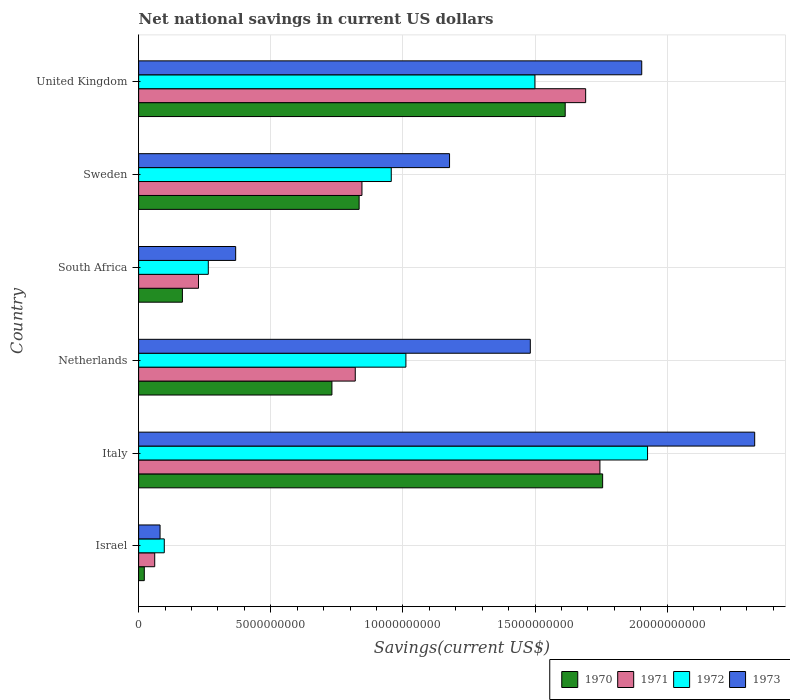How many different coloured bars are there?
Provide a short and direct response. 4. How many groups of bars are there?
Provide a succinct answer. 6. How many bars are there on the 3rd tick from the top?
Offer a very short reply. 4. How many bars are there on the 3rd tick from the bottom?
Provide a succinct answer. 4. What is the label of the 2nd group of bars from the top?
Offer a terse response. Sweden. In how many cases, is the number of bars for a given country not equal to the number of legend labels?
Give a very brief answer. 0. What is the net national savings in 1972 in United Kingdom?
Your answer should be very brief. 1.50e+1. Across all countries, what is the maximum net national savings in 1970?
Offer a very short reply. 1.76e+1. Across all countries, what is the minimum net national savings in 1973?
Provide a short and direct response. 8.11e+08. In which country was the net national savings in 1973 maximum?
Offer a terse response. Italy. What is the total net national savings in 1972 in the graph?
Your answer should be compact. 5.75e+1. What is the difference between the net national savings in 1972 in Israel and that in United Kingdom?
Your answer should be compact. -1.40e+1. What is the difference between the net national savings in 1972 in United Kingdom and the net national savings in 1970 in Israel?
Ensure brevity in your answer.  1.48e+1. What is the average net national savings in 1970 per country?
Give a very brief answer. 8.54e+09. What is the difference between the net national savings in 1973 and net national savings in 1971 in Israel?
Provide a short and direct response. 2.02e+08. What is the ratio of the net national savings in 1972 in Netherlands to that in United Kingdom?
Ensure brevity in your answer.  0.67. What is the difference between the highest and the second highest net national savings in 1971?
Make the answer very short. 5.40e+08. What is the difference between the highest and the lowest net national savings in 1971?
Provide a succinct answer. 1.68e+1. In how many countries, is the net national savings in 1972 greater than the average net national savings in 1972 taken over all countries?
Your answer should be very brief. 3. Is the sum of the net national savings in 1970 in South Africa and United Kingdom greater than the maximum net national savings in 1972 across all countries?
Keep it short and to the point. No. Is it the case that in every country, the sum of the net national savings in 1973 and net national savings in 1972 is greater than the sum of net national savings in 1970 and net national savings in 1971?
Offer a terse response. No. What does the 1st bar from the bottom in Netherlands represents?
Ensure brevity in your answer.  1970. How many bars are there?
Keep it short and to the point. 24. How many countries are there in the graph?
Make the answer very short. 6. How many legend labels are there?
Provide a short and direct response. 4. How are the legend labels stacked?
Make the answer very short. Horizontal. What is the title of the graph?
Provide a succinct answer. Net national savings in current US dollars. What is the label or title of the X-axis?
Provide a short and direct response. Savings(current US$). What is the Savings(current US$) in 1970 in Israel?
Your response must be concise. 2.15e+08. What is the Savings(current US$) in 1971 in Israel?
Offer a terse response. 6.09e+08. What is the Savings(current US$) in 1972 in Israel?
Offer a very short reply. 9.71e+08. What is the Savings(current US$) of 1973 in Israel?
Your answer should be very brief. 8.11e+08. What is the Savings(current US$) in 1970 in Italy?
Ensure brevity in your answer.  1.76e+1. What is the Savings(current US$) in 1971 in Italy?
Provide a succinct answer. 1.75e+1. What is the Savings(current US$) in 1972 in Italy?
Offer a terse response. 1.93e+1. What is the Savings(current US$) in 1973 in Italy?
Ensure brevity in your answer.  2.33e+1. What is the Savings(current US$) in 1970 in Netherlands?
Your response must be concise. 7.31e+09. What is the Savings(current US$) of 1971 in Netherlands?
Offer a very short reply. 8.20e+09. What is the Savings(current US$) in 1972 in Netherlands?
Offer a terse response. 1.01e+1. What is the Savings(current US$) in 1973 in Netherlands?
Ensure brevity in your answer.  1.48e+1. What is the Savings(current US$) of 1970 in South Africa?
Offer a very short reply. 1.66e+09. What is the Savings(current US$) in 1971 in South Africa?
Ensure brevity in your answer.  2.27e+09. What is the Savings(current US$) of 1972 in South Africa?
Offer a terse response. 2.64e+09. What is the Savings(current US$) in 1973 in South Africa?
Provide a succinct answer. 3.67e+09. What is the Savings(current US$) of 1970 in Sweden?
Offer a terse response. 8.34e+09. What is the Savings(current US$) in 1971 in Sweden?
Keep it short and to the point. 8.45e+09. What is the Savings(current US$) of 1972 in Sweden?
Provide a succinct answer. 9.56e+09. What is the Savings(current US$) in 1973 in Sweden?
Give a very brief answer. 1.18e+1. What is the Savings(current US$) of 1970 in United Kingdom?
Make the answer very short. 1.61e+1. What is the Savings(current US$) of 1971 in United Kingdom?
Your response must be concise. 1.69e+1. What is the Savings(current US$) in 1972 in United Kingdom?
Offer a very short reply. 1.50e+1. What is the Savings(current US$) of 1973 in United Kingdom?
Your response must be concise. 1.90e+1. Across all countries, what is the maximum Savings(current US$) in 1970?
Provide a short and direct response. 1.76e+1. Across all countries, what is the maximum Savings(current US$) in 1971?
Ensure brevity in your answer.  1.75e+1. Across all countries, what is the maximum Savings(current US$) in 1972?
Make the answer very short. 1.93e+1. Across all countries, what is the maximum Savings(current US$) of 1973?
Keep it short and to the point. 2.33e+1. Across all countries, what is the minimum Savings(current US$) of 1970?
Make the answer very short. 2.15e+08. Across all countries, what is the minimum Savings(current US$) of 1971?
Your answer should be very brief. 6.09e+08. Across all countries, what is the minimum Savings(current US$) of 1972?
Ensure brevity in your answer.  9.71e+08. Across all countries, what is the minimum Savings(current US$) in 1973?
Ensure brevity in your answer.  8.11e+08. What is the total Savings(current US$) of 1970 in the graph?
Ensure brevity in your answer.  5.12e+1. What is the total Savings(current US$) in 1971 in the graph?
Offer a very short reply. 5.39e+1. What is the total Savings(current US$) in 1972 in the graph?
Provide a short and direct response. 5.75e+1. What is the total Savings(current US$) of 1973 in the graph?
Ensure brevity in your answer.  7.34e+1. What is the difference between the Savings(current US$) of 1970 in Israel and that in Italy?
Ensure brevity in your answer.  -1.73e+1. What is the difference between the Savings(current US$) in 1971 in Israel and that in Italy?
Provide a short and direct response. -1.68e+1. What is the difference between the Savings(current US$) in 1972 in Israel and that in Italy?
Provide a succinct answer. -1.83e+1. What is the difference between the Savings(current US$) in 1973 in Israel and that in Italy?
Your answer should be compact. -2.25e+1. What is the difference between the Savings(current US$) of 1970 in Israel and that in Netherlands?
Give a very brief answer. -7.10e+09. What is the difference between the Savings(current US$) of 1971 in Israel and that in Netherlands?
Your answer should be very brief. -7.59e+09. What is the difference between the Savings(current US$) of 1972 in Israel and that in Netherlands?
Offer a very short reply. -9.14e+09. What is the difference between the Savings(current US$) of 1973 in Israel and that in Netherlands?
Make the answer very short. -1.40e+1. What is the difference between the Savings(current US$) in 1970 in Israel and that in South Africa?
Offer a very short reply. -1.44e+09. What is the difference between the Savings(current US$) in 1971 in Israel and that in South Africa?
Make the answer very short. -1.66e+09. What is the difference between the Savings(current US$) in 1972 in Israel and that in South Africa?
Ensure brevity in your answer.  -1.66e+09. What is the difference between the Savings(current US$) in 1973 in Israel and that in South Africa?
Provide a short and direct response. -2.86e+09. What is the difference between the Savings(current US$) of 1970 in Israel and that in Sweden?
Your answer should be very brief. -8.13e+09. What is the difference between the Savings(current US$) of 1971 in Israel and that in Sweden?
Make the answer very short. -7.84e+09. What is the difference between the Savings(current US$) in 1972 in Israel and that in Sweden?
Your answer should be compact. -8.59e+09. What is the difference between the Savings(current US$) in 1973 in Israel and that in Sweden?
Your answer should be compact. -1.10e+1. What is the difference between the Savings(current US$) in 1970 in Israel and that in United Kingdom?
Give a very brief answer. -1.59e+1. What is the difference between the Savings(current US$) of 1971 in Israel and that in United Kingdom?
Make the answer very short. -1.63e+1. What is the difference between the Savings(current US$) of 1972 in Israel and that in United Kingdom?
Make the answer very short. -1.40e+1. What is the difference between the Savings(current US$) of 1973 in Israel and that in United Kingdom?
Your answer should be very brief. -1.82e+1. What is the difference between the Savings(current US$) in 1970 in Italy and that in Netherlands?
Provide a succinct answer. 1.02e+1. What is the difference between the Savings(current US$) of 1971 in Italy and that in Netherlands?
Your response must be concise. 9.26e+09. What is the difference between the Savings(current US$) in 1972 in Italy and that in Netherlands?
Ensure brevity in your answer.  9.14e+09. What is the difference between the Savings(current US$) of 1973 in Italy and that in Netherlands?
Offer a terse response. 8.49e+09. What is the difference between the Savings(current US$) in 1970 in Italy and that in South Africa?
Your response must be concise. 1.59e+1. What is the difference between the Savings(current US$) in 1971 in Italy and that in South Africa?
Ensure brevity in your answer.  1.52e+1. What is the difference between the Savings(current US$) of 1972 in Italy and that in South Africa?
Provide a short and direct response. 1.66e+1. What is the difference between the Savings(current US$) in 1973 in Italy and that in South Africa?
Your response must be concise. 1.96e+1. What is the difference between the Savings(current US$) of 1970 in Italy and that in Sweden?
Provide a short and direct response. 9.21e+09. What is the difference between the Savings(current US$) of 1971 in Italy and that in Sweden?
Provide a succinct answer. 9.00e+09. What is the difference between the Savings(current US$) of 1972 in Italy and that in Sweden?
Ensure brevity in your answer.  9.70e+09. What is the difference between the Savings(current US$) in 1973 in Italy and that in Sweden?
Your answer should be very brief. 1.15e+1. What is the difference between the Savings(current US$) in 1970 in Italy and that in United Kingdom?
Your answer should be compact. 1.42e+09. What is the difference between the Savings(current US$) of 1971 in Italy and that in United Kingdom?
Give a very brief answer. 5.40e+08. What is the difference between the Savings(current US$) of 1972 in Italy and that in United Kingdom?
Your response must be concise. 4.26e+09. What is the difference between the Savings(current US$) in 1973 in Italy and that in United Kingdom?
Offer a terse response. 4.27e+09. What is the difference between the Savings(current US$) in 1970 in Netherlands and that in South Africa?
Keep it short and to the point. 5.66e+09. What is the difference between the Savings(current US$) in 1971 in Netherlands and that in South Africa?
Provide a short and direct response. 5.93e+09. What is the difference between the Savings(current US$) of 1972 in Netherlands and that in South Africa?
Offer a terse response. 7.48e+09. What is the difference between the Savings(current US$) of 1973 in Netherlands and that in South Africa?
Give a very brief answer. 1.11e+1. What is the difference between the Savings(current US$) of 1970 in Netherlands and that in Sweden?
Offer a very short reply. -1.03e+09. What is the difference between the Savings(current US$) of 1971 in Netherlands and that in Sweden?
Provide a succinct answer. -2.53e+08. What is the difference between the Savings(current US$) in 1972 in Netherlands and that in Sweden?
Keep it short and to the point. 5.54e+08. What is the difference between the Savings(current US$) in 1973 in Netherlands and that in Sweden?
Offer a terse response. 3.06e+09. What is the difference between the Savings(current US$) in 1970 in Netherlands and that in United Kingdom?
Your response must be concise. -8.83e+09. What is the difference between the Savings(current US$) of 1971 in Netherlands and that in United Kingdom?
Your answer should be compact. -8.72e+09. What is the difference between the Savings(current US$) in 1972 in Netherlands and that in United Kingdom?
Your answer should be very brief. -4.88e+09. What is the difference between the Savings(current US$) of 1973 in Netherlands and that in United Kingdom?
Make the answer very short. -4.22e+09. What is the difference between the Savings(current US$) of 1970 in South Africa and that in Sweden?
Your answer should be compact. -6.69e+09. What is the difference between the Savings(current US$) in 1971 in South Africa and that in Sweden?
Keep it short and to the point. -6.18e+09. What is the difference between the Savings(current US$) in 1972 in South Africa and that in Sweden?
Offer a terse response. -6.92e+09. What is the difference between the Savings(current US$) in 1973 in South Africa and that in Sweden?
Provide a short and direct response. -8.09e+09. What is the difference between the Savings(current US$) in 1970 in South Africa and that in United Kingdom?
Give a very brief answer. -1.45e+1. What is the difference between the Savings(current US$) in 1971 in South Africa and that in United Kingdom?
Provide a short and direct response. -1.46e+1. What is the difference between the Savings(current US$) in 1972 in South Africa and that in United Kingdom?
Provide a short and direct response. -1.24e+1. What is the difference between the Savings(current US$) of 1973 in South Africa and that in United Kingdom?
Offer a very short reply. -1.54e+1. What is the difference between the Savings(current US$) of 1970 in Sweden and that in United Kingdom?
Provide a short and direct response. -7.80e+09. What is the difference between the Savings(current US$) in 1971 in Sweden and that in United Kingdom?
Your answer should be very brief. -8.46e+09. What is the difference between the Savings(current US$) of 1972 in Sweden and that in United Kingdom?
Your answer should be compact. -5.43e+09. What is the difference between the Savings(current US$) in 1973 in Sweden and that in United Kingdom?
Offer a very short reply. -7.27e+09. What is the difference between the Savings(current US$) of 1970 in Israel and the Savings(current US$) of 1971 in Italy?
Offer a very short reply. -1.72e+1. What is the difference between the Savings(current US$) in 1970 in Israel and the Savings(current US$) in 1972 in Italy?
Keep it short and to the point. -1.90e+1. What is the difference between the Savings(current US$) of 1970 in Israel and the Savings(current US$) of 1973 in Italy?
Ensure brevity in your answer.  -2.31e+1. What is the difference between the Savings(current US$) of 1971 in Israel and the Savings(current US$) of 1972 in Italy?
Your answer should be very brief. -1.86e+1. What is the difference between the Savings(current US$) of 1971 in Israel and the Savings(current US$) of 1973 in Italy?
Provide a succinct answer. -2.27e+1. What is the difference between the Savings(current US$) of 1972 in Israel and the Savings(current US$) of 1973 in Italy?
Give a very brief answer. -2.23e+1. What is the difference between the Savings(current US$) in 1970 in Israel and the Savings(current US$) in 1971 in Netherlands?
Your response must be concise. -7.98e+09. What is the difference between the Savings(current US$) in 1970 in Israel and the Savings(current US$) in 1972 in Netherlands?
Offer a terse response. -9.90e+09. What is the difference between the Savings(current US$) in 1970 in Israel and the Savings(current US$) in 1973 in Netherlands?
Provide a succinct answer. -1.46e+1. What is the difference between the Savings(current US$) of 1971 in Israel and the Savings(current US$) of 1972 in Netherlands?
Make the answer very short. -9.50e+09. What is the difference between the Savings(current US$) in 1971 in Israel and the Savings(current US$) in 1973 in Netherlands?
Offer a very short reply. -1.42e+1. What is the difference between the Savings(current US$) of 1972 in Israel and the Savings(current US$) of 1973 in Netherlands?
Your response must be concise. -1.38e+1. What is the difference between the Savings(current US$) of 1970 in Israel and the Savings(current US$) of 1971 in South Africa?
Your response must be concise. -2.05e+09. What is the difference between the Savings(current US$) of 1970 in Israel and the Savings(current US$) of 1972 in South Africa?
Your answer should be compact. -2.42e+09. What is the difference between the Savings(current US$) in 1970 in Israel and the Savings(current US$) in 1973 in South Africa?
Provide a succinct answer. -3.46e+09. What is the difference between the Savings(current US$) of 1971 in Israel and the Savings(current US$) of 1972 in South Africa?
Keep it short and to the point. -2.03e+09. What is the difference between the Savings(current US$) of 1971 in Israel and the Savings(current US$) of 1973 in South Africa?
Provide a short and direct response. -3.06e+09. What is the difference between the Savings(current US$) of 1972 in Israel and the Savings(current US$) of 1973 in South Africa?
Make the answer very short. -2.70e+09. What is the difference between the Savings(current US$) in 1970 in Israel and the Savings(current US$) in 1971 in Sweden?
Your answer should be very brief. -8.23e+09. What is the difference between the Savings(current US$) of 1970 in Israel and the Savings(current US$) of 1972 in Sweden?
Make the answer very short. -9.34e+09. What is the difference between the Savings(current US$) of 1970 in Israel and the Savings(current US$) of 1973 in Sweden?
Make the answer very short. -1.15e+1. What is the difference between the Savings(current US$) in 1971 in Israel and the Savings(current US$) in 1972 in Sweden?
Your response must be concise. -8.95e+09. What is the difference between the Savings(current US$) of 1971 in Israel and the Savings(current US$) of 1973 in Sweden?
Your response must be concise. -1.12e+1. What is the difference between the Savings(current US$) in 1972 in Israel and the Savings(current US$) in 1973 in Sweden?
Your response must be concise. -1.08e+1. What is the difference between the Savings(current US$) of 1970 in Israel and the Savings(current US$) of 1971 in United Kingdom?
Provide a short and direct response. -1.67e+1. What is the difference between the Savings(current US$) in 1970 in Israel and the Savings(current US$) in 1972 in United Kingdom?
Provide a succinct answer. -1.48e+1. What is the difference between the Savings(current US$) of 1970 in Israel and the Savings(current US$) of 1973 in United Kingdom?
Offer a terse response. -1.88e+1. What is the difference between the Savings(current US$) of 1971 in Israel and the Savings(current US$) of 1972 in United Kingdom?
Offer a very short reply. -1.44e+1. What is the difference between the Savings(current US$) in 1971 in Israel and the Savings(current US$) in 1973 in United Kingdom?
Your response must be concise. -1.84e+1. What is the difference between the Savings(current US$) of 1972 in Israel and the Savings(current US$) of 1973 in United Kingdom?
Provide a succinct answer. -1.81e+1. What is the difference between the Savings(current US$) of 1970 in Italy and the Savings(current US$) of 1971 in Netherlands?
Ensure brevity in your answer.  9.36e+09. What is the difference between the Savings(current US$) of 1970 in Italy and the Savings(current US$) of 1972 in Netherlands?
Ensure brevity in your answer.  7.44e+09. What is the difference between the Savings(current US$) of 1970 in Italy and the Savings(current US$) of 1973 in Netherlands?
Your answer should be very brief. 2.74e+09. What is the difference between the Savings(current US$) in 1971 in Italy and the Savings(current US$) in 1972 in Netherlands?
Provide a short and direct response. 7.34e+09. What is the difference between the Savings(current US$) in 1971 in Italy and the Savings(current US$) in 1973 in Netherlands?
Give a very brief answer. 2.63e+09. What is the difference between the Savings(current US$) in 1972 in Italy and the Savings(current US$) in 1973 in Netherlands?
Give a very brief answer. 4.44e+09. What is the difference between the Savings(current US$) of 1970 in Italy and the Savings(current US$) of 1971 in South Africa?
Your answer should be compact. 1.53e+1. What is the difference between the Savings(current US$) of 1970 in Italy and the Savings(current US$) of 1972 in South Africa?
Offer a very short reply. 1.49e+1. What is the difference between the Savings(current US$) of 1970 in Italy and the Savings(current US$) of 1973 in South Africa?
Ensure brevity in your answer.  1.39e+1. What is the difference between the Savings(current US$) of 1971 in Italy and the Savings(current US$) of 1972 in South Africa?
Provide a succinct answer. 1.48e+1. What is the difference between the Savings(current US$) of 1971 in Italy and the Savings(current US$) of 1973 in South Africa?
Offer a terse response. 1.38e+1. What is the difference between the Savings(current US$) of 1972 in Italy and the Savings(current US$) of 1973 in South Africa?
Your response must be concise. 1.56e+1. What is the difference between the Savings(current US$) in 1970 in Italy and the Savings(current US$) in 1971 in Sweden?
Provide a short and direct response. 9.11e+09. What is the difference between the Savings(current US$) in 1970 in Italy and the Savings(current US$) in 1972 in Sweden?
Offer a very short reply. 8.00e+09. What is the difference between the Savings(current US$) of 1970 in Italy and the Savings(current US$) of 1973 in Sweden?
Your answer should be very brief. 5.79e+09. What is the difference between the Savings(current US$) of 1971 in Italy and the Savings(current US$) of 1972 in Sweden?
Provide a short and direct response. 7.89e+09. What is the difference between the Savings(current US$) of 1971 in Italy and the Savings(current US$) of 1973 in Sweden?
Give a very brief answer. 5.69e+09. What is the difference between the Savings(current US$) of 1972 in Italy and the Savings(current US$) of 1973 in Sweden?
Provide a short and direct response. 7.49e+09. What is the difference between the Savings(current US$) of 1970 in Italy and the Savings(current US$) of 1971 in United Kingdom?
Provide a succinct answer. 6.43e+08. What is the difference between the Savings(current US$) of 1970 in Italy and the Savings(current US$) of 1972 in United Kingdom?
Your answer should be compact. 2.56e+09. What is the difference between the Savings(current US$) of 1970 in Italy and the Savings(current US$) of 1973 in United Kingdom?
Your response must be concise. -1.48e+09. What is the difference between the Savings(current US$) of 1971 in Italy and the Savings(current US$) of 1972 in United Kingdom?
Provide a short and direct response. 2.46e+09. What is the difference between the Savings(current US$) of 1971 in Italy and the Savings(current US$) of 1973 in United Kingdom?
Keep it short and to the point. -1.58e+09. What is the difference between the Savings(current US$) of 1972 in Italy and the Savings(current US$) of 1973 in United Kingdom?
Give a very brief answer. 2.20e+08. What is the difference between the Savings(current US$) of 1970 in Netherlands and the Savings(current US$) of 1971 in South Africa?
Provide a succinct answer. 5.05e+09. What is the difference between the Savings(current US$) of 1970 in Netherlands and the Savings(current US$) of 1972 in South Africa?
Give a very brief answer. 4.68e+09. What is the difference between the Savings(current US$) in 1970 in Netherlands and the Savings(current US$) in 1973 in South Africa?
Make the answer very short. 3.64e+09. What is the difference between the Savings(current US$) in 1971 in Netherlands and the Savings(current US$) in 1972 in South Africa?
Offer a terse response. 5.56e+09. What is the difference between the Savings(current US$) in 1971 in Netherlands and the Savings(current US$) in 1973 in South Africa?
Give a very brief answer. 4.52e+09. What is the difference between the Savings(current US$) of 1972 in Netherlands and the Savings(current US$) of 1973 in South Africa?
Your response must be concise. 6.44e+09. What is the difference between the Savings(current US$) in 1970 in Netherlands and the Savings(current US$) in 1971 in Sweden?
Make the answer very short. -1.14e+09. What is the difference between the Savings(current US$) in 1970 in Netherlands and the Savings(current US$) in 1972 in Sweden?
Give a very brief answer. -2.25e+09. What is the difference between the Savings(current US$) of 1970 in Netherlands and the Savings(current US$) of 1973 in Sweden?
Ensure brevity in your answer.  -4.45e+09. What is the difference between the Savings(current US$) in 1971 in Netherlands and the Savings(current US$) in 1972 in Sweden?
Your answer should be very brief. -1.36e+09. What is the difference between the Savings(current US$) in 1971 in Netherlands and the Savings(current US$) in 1973 in Sweden?
Offer a very short reply. -3.57e+09. What is the difference between the Savings(current US$) of 1972 in Netherlands and the Savings(current US$) of 1973 in Sweden?
Offer a terse response. -1.65e+09. What is the difference between the Savings(current US$) in 1970 in Netherlands and the Savings(current US$) in 1971 in United Kingdom?
Provide a short and direct response. -9.60e+09. What is the difference between the Savings(current US$) in 1970 in Netherlands and the Savings(current US$) in 1972 in United Kingdom?
Offer a terse response. -7.68e+09. What is the difference between the Savings(current US$) of 1970 in Netherlands and the Savings(current US$) of 1973 in United Kingdom?
Keep it short and to the point. -1.17e+1. What is the difference between the Savings(current US$) in 1971 in Netherlands and the Savings(current US$) in 1972 in United Kingdom?
Give a very brief answer. -6.80e+09. What is the difference between the Savings(current US$) in 1971 in Netherlands and the Savings(current US$) in 1973 in United Kingdom?
Ensure brevity in your answer.  -1.08e+1. What is the difference between the Savings(current US$) of 1972 in Netherlands and the Savings(current US$) of 1973 in United Kingdom?
Your answer should be very brief. -8.92e+09. What is the difference between the Savings(current US$) of 1970 in South Africa and the Savings(current US$) of 1971 in Sweden?
Provide a short and direct response. -6.79e+09. What is the difference between the Savings(current US$) in 1970 in South Africa and the Savings(current US$) in 1972 in Sweden?
Your response must be concise. -7.90e+09. What is the difference between the Savings(current US$) of 1970 in South Africa and the Savings(current US$) of 1973 in Sweden?
Your response must be concise. -1.01e+1. What is the difference between the Savings(current US$) of 1971 in South Africa and the Savings(current US$) of 1972 in Sweden?
Provide a short and direct response. -7.29e+09. What is the difference between the Savings(current US$) of 1971 in South Africa and the Savings(current US$) of 1973 in Sweden?
Provide a succinct answer. -9.50e+09. What is the difference between the Savings(current US$) in 1972 in South Africa and the Savings(current US$) in 1973 in Sweden?
Your response must be concise. -9.13e+09. What is the difference between the Savings(current US$) of 1970 in South Africa and the Savings(current US$) of 1971 in United Kingdom?
Your answer should be very brief. -1.53e+1. What is the difference between the Savings(current US$) in 1970 in South Africa and the Savings(current US$) in 1972 in United Kingdom?
Make the answer very short. -1.33e+1. What is the difference between the Savings(current US$) of 1970 in South Africa and the Savings(current US$) of 1973 in United Kingdom?
Your response must be concise. -1.74e+1. What is the difference between the Savings(current US$) in 1971 in South Africa and the Savings(current US$) in 1972 in United Kingdom?
Offer a very short reply. -1.27e+1. What is the difference between the Savings(current US$) of 1971 in South Africa and the Savings(current US$) of 1973 in United Kingdom?
Give a very brief answer. -1.68e+1. What is the difference between the Savings(current US$) in 1972 in South Africa and the Savings(current US$) in 1973 in United Kingdom?
Keep it short and to the point. -1.64e+1. What is the difference between the Savings(current US$) in 1970 in Sweden and the Savings(current US$) in 1971 in United Kingdom?
Give a very brief answer. -8.57e+09. What is the difference between the Savings(current US$) of 1970 in Sweden and the Savings(current US$) of 1972 in United Kingdom?
Offer a terse response. -6.65e+09. What is the difference between the Savings(current US$) in 1970 in Sweden and the Savings(current US$) in 1973 in United Kingdom?
Provide a succinct answer. -1.07e+1. What is the difference between the Savings(current US$) in 1971 in Sweden and the Savings(current US$) in 1972 in United Kingdom?
Give a very brief answer. -6.54e+09. What is the difference between the Savings(current US$) of 1971 in Sweden and the Savings(current US$) of 1973 in United Kingdom?
Give a very brief answer. -1.06e+1. What is the difference between the Savings(current US$) in 1972 in Sweden and the Savings(current US$) in 1973 in United Kingdom?
Provide a short and direct response. -9.48e+09. What is the average Savings(current US$) in 1970 per country?
Your answer should be compact. 8.54e+09. What is the average Savings(current US$) in 1971 per country?
Your answer should be very brief. 8.98e+09. What is the average Savings(current US$) in 1972 per country?
Provide a succinct answer. 9.59e+09. What is the average Savings(current US$) in 1973 per country?
Provide a succinct answer. 1.22e+1. What is the difference between the Savings(current US$) in 1970 and Savings(current US$) in 1971 in Israel?
Make the answer very short. -3.94e+08. What is the difference between the Savings(current US$) in 1970 and Savings(current US$) in 1972 in Israel?
Your answer should be compact. -7.56e+08. What is the difference between the Savings(current US$) of 1970 and Savings(current US$) of 1973 in Israel?
Ensure brevity in your answer.  -5.96e+08. What is the difference between the Savings(current US$) in 1971 and Savings(current US$) in 1972 in Israel?
Your answer should be compact. -3.62e+08. What is the difference between the Savings(current US$) in 1971 and Savings(current US$) in 1973 in Israel?
Keep it short and to the point. -2.02e+08. What is the difference between the Savings(current US$) of 1972 and Savings(current US$) of 1973 in Israel?
Your response must be concise. 1.60e+08. What is the difference between the Savings(current US$) of 1970 and Savings(current US$) of 1971 in Italy?
Keep it short and to the point. 1.03e+08. What is the difference between the Savings(current US$) in 1970 and Savings(current US$) in 1972 in Italy?
Keep it short and to the point. -1.70e+09. What is the difference between the Savings(current US$) in 1970 and Savings(current US$) in 1973 in Italy?
Your answer should be compact. -5.75e+09. What is the difference between the Savings(current US$) in 1971 and Savings(current US$) in 1972 in Italy?
Ensure brevity in your answer.  -1.80e+09. What is the difference between the Savings(current US$) in 1971 and Savings(current US$) in 1973 in Italy?
Give a very brief answer. -5.86e+09. What is the difference between the Savings(current US$) in 1972 and Savings(current US$) in 1973 in Italy?
Keep it short and to the point. -4.05e+09. What is the difference between the Savings(current US$) of 1970 and Savings(current US$) of 1971 in Netherlands?
Your response must be concise. -8.83e+08. What is the difference between the Savings(current US$) of 1970 and Savings(current US$) of 1972 in Netherlands?
Ensure brevity in your answer.  -2.80e+09. What is the difference between the Savings(current US$) in 1970 and Savings(current US$) in 1973 in Netherlands?
Ensure brevity in your answer.  -7.51e+09. What is the difference between the Savings(current US$) of 1971 and Savings(current US$) of 1972 in Netherlands?
Offer a terse response. -1.92e+09. What is the difference between the Savings(current US$) of 1971 and Savings(current US$) of 1973 in Netherlands?
Your answer should be very brief. -6.62e+09. What is the difference between the Savings(current US$) in 1972 and Savings(current US$) in 1973 in Netherlands?
Your answer should be compact. -4.71e+09. What is the difference between the Savings(current US$) in 1970 and Savings(current US$) in 1971 in South Africa?
Keep it short and to the point. -6.09e+08. What is the difference between the Savings(current US$) of 1970 and Savings(current US$) of 1972 in South Africa?
Keep it short and to the point. -9.79e+08. What is the difference between the Savings(current US$) of 1970 and Savings(current US$) of 1973 in South Africa?
Offer a very short reply. -2.02e+09. What is the difference between the Savings(current US$) in 1971 and Savings(current US$) in 1972 in South Africa?
Provide a succinct answer. -3.70e+08. What is the difference between the Savings(current US$) of 1971 and Savings(current US$) of 1973 in South Africa?
Your response must be concise. -1.41e+09. What is the difference between the Savings(current US$) of 1972 and Savings(current US$) of 1973 in South Africa?
Provide a short and direct response. -1.04e+09. What is the difference between the Savings(current US$) in 1970 and Savings(current US$) in 1971 in Sweden?
Your answer should be compact. -1.07e+08. What is the difference between the Savings(current US$) of 1970 and Savings(current US$) of 1972 in Sweden?
Provide a succinct answer. -1.22e+09. What is the difference between the Savings(current US$) of 1970 and Savings(current US$) of 1973 in Sweden?
Give a very brief answer. -3.42e+09. What is the difference between the Savings(current US$) in 1971 and Savings(current US$) in 1972 in Sweden?
Offer a very short reply. -1.11e+09. What is the difference between the Savings(current US$) of 1971 and Savings(current US$) of 1973 in Sweden?
Provide a short and direct response. -3.31e+09. What is the difference between the Savings(current US$) in 1972 and Savings(current US$) in 1973 in Sweden?
Your answer should be compact. -2.20e+09. What is the difference between the Savings(current US$) of 1970 and Savings(current US$) of 1971 in United Kingdom?
Give a very brief answer. -7.74e+08. What is the difference between the Savings(current US$) in 1970 and Savings(current US$) in 1972 in United Kingdom?
Keep it short and to the point. 1.15e+09. What is the difference between the Savings(current US$) in 1970 and Savings(current US$) in 1973 in United Kingdom?
Offer a very short reply. -2.90e+09. What is the difference between the Savings(current US$) in 1971 and Savings(current US$) in 1972 in United Kingdom?
Offer a very short reply. 1.92e+09. What is the difference between the Savings(current US$) in 1971 and Savings(current US$) in 1973 in United Kingdom?
Your answer should be very brief. -2.12e+09. What is the difference between the Savings(current US$) of 1972 and Savings(current US$) of 1973 in United Kingdom?
Offer a very short reply. -4.04e+09. What is the ratio of the Savings(current US$) of 1970 in Israel to that in Italy?
Ensure brevity in your answer.  0.01. What is the ratio of the Savings(current US$) of 1971 in Israel to that in Italy?
Give a very brief answer. 0.03. What is the ratio of the Savings(current US$) in 1972 in Israel to that in Italy?
Provide a short and direct response. 0.05. What is the ratio of the Savings(current US$) of 1973 in Israel to that in Italy?
Make the answer very short. 0.03. What is the ratio of the Savings(current US$) of 1970 in Israel to that in Netherlands?
Offer a very short reply. 0.03. What is the ratio of the Savings(current US$) in 1971 in Israel to that in Netherlands?
Offer a very short reply. 0.07. What is the ratio of the Savings(current US$) of 1972 in Israel to that in Netherlands?
Your answer should be very brief. 0.1. What is the ratio of the Savings(current US$) in 1973 in Israel to that in Netherlands?
Your response must be concise. 0.05. What is the ratio of the Savings(current US$) of 1970 in Israel to that in South Africa?
Ensure brevity in your answer.  0.13. What is the ratio of the Savings(current US$) of 1971 in Israel to that in South Africa?
Ensure brevity in your answer.  0.27. What is the ratio of the Savings(current US$) of 1972 in Israel to that in South Africa?
Provide a succinct answer. 0.37. What is the ratio of the Savings(current US$) of 1973 in Israel to that in South Africa?
Provide a succinct answer. 0.22. What is the ratio of the Savings(current US$) in 1970 in Israel to that in Sweden?
Your response must be concise. 0.03. What is the ratio of the Savings(current US$) in 1971 in Israel to that in Sweden?
Make the answer very short. 0.07. What is the ratio of the Savings(current US$) of 1972 in Israel to that in Sweden?
Make the answer very short. 0.1. What is the ratio of the Savings(current US$) in 1973 in Israel to that in Sweden?
Give a very brief answer. 0.07. What is the ratio of the Savings(current US$) of 1970 in Israel to that in United Kingdom?
Provide a succinct answer. 0.01. What is the ratio of the Savings(current US$) of 1971 in Israel to that in United Kingdom?
Keep it short and to the point. 0.04. What is the ratio of the Savings(current US$) of 1972 in Israel to that in United Kingdom?
Your response must be concise. 0.06. What is the ratio of the Savings(current US$) of 1973 in Israel to that in United Kingdom?
Make the answer very short. 0.04. What is the ratio of the Savings(current US$) of 1970 in Italy to that in Netherlands?
Your answer should be compact. 2.4. What is the ratio of the Savings(current US$) in 1971 in Italy to that in Netherlands?
Provide a succinct answer. 2.13. What is the ratio of the Savings(current US$) of 1972 in Italy to that in Netherlands?
Provide a short and direct response. 1.9. What is the ratio of the Savings(current US$) of 1973 in Italy to that in Netherlands?
Your response must be concise. 1.57. What is the ratio of the Savings(current US$) in 1970 in Italy to that in South Africa?
Your answer should be very brief. 10.6. What is the ratio of the Savings(current US$) in 1971 in Italy to that in South Africa?
Make the answer very short. 7.7. What is the ratio of the Savings(current US$) in 1972 in Italy to that in South Africa?
Provide a short and direct response. 7.31. What is the ratio of the Savings(current US$) of 1973 in Italy to that in South Africa?
Ensure brevity in your answer.  6.35. What is the ratio of the Savings(current US$) in 1970 in Italy to that in Sweden?
Provide a short and direct response. 2.1. What is the ratio of the Savings(current US$) in 1971 in Italy to that in Sweden?
Make the answer very short. 2.07. What is the ratio of the Savings(current US$) in 1972 in Italy to that in Sweden?
Offer a very short reply. 2.01. What is the ratio of the Savings(current US$) in 1973 in Italy to that in Sweden?
Keep it short and to the point. 1.98. What is the ratio of the Savings(current US$) of 1970 in Italy to that in United Kingdom?
Your response must be concise. 1.09. What is the ratio of the Savings(current US$) of 1971 in Italy to that in United Kingdom?
Keep it short and to the point. 1.03. What is the ratio of the Savings(current US$) in 1972 in Italy to that in United Kingdom?
Your response must be concise. 1.28. What is the ratio of the Savings(current US$) of 1973 in Italy to that in United Kingdom?
Make the answer very short. 1.22. What is the ratio of the Savings(current US$) in 1970 in Netherlands to that in South Africa?
Ensure brevity in your answer.  4.42. What is the ratio of the Savings(current US$) in 1971 in Netherlands to that in South Africa?
Give a very brief answer. 3.62. What is the ratio of the Savings(current US$) in 1972 in Netherlands to that in South Africa?
Make the answer very short. 3.84. What is the ratio of the Savings(current US$) of 1973 in Netherlands to that in South Africa?
Your answer should be compact. 4.04. What is the ratio of the Savings(current US$) in 1970 in Netherlands to that in Sweden?
Give a very brief answer. 0.88. What is the ratio of the Savings(current US$) of 1972 in Netherlands to that in Sweden?
Provide a short and direct response. 1.06. What is the ratio of the Savings(current US$) of 1973 in Netherlands to that in Sweden?
Give a very brief answer. 1.26. What is the ratio of the Savings(current US$) of 1970 in Netherlands to that in United Kingdom?
Your response must be concise. 0.45. What is the ratio of the Savings(current US$) in 1971 in Netherlands to that in United Kingdom?
Your response must be concise. 0.48. What is the ratio of the Savings(current US$) in 1972 in Netherlands to that in United Kingdom?
Your response must be concise. 0.67. What is the ratio of the Savings(current US$) in 1973 in Netherlands to that in United Kingdom?
Ensure brevity in your answer.  0.78. What is the ratio of the Savings(current US$) in 1970 in South Africa to that in Sweden?
Your answer should be very brief. 0.2. What is the ratio of the Savings(current US$) of 1971 in South Africa to that in Sweden?
Make the answer very short. 0.27. What is the ratio of the Savings(current US$) of 1972 in South Africa to that in Sweden?
Make the answer very short. 0.28. What is the ratio of the Savings(current US$) of 1973 in South Africa to that in Sweden?
Offer a terse response. 0.31. What is the ratio of the Savings(current US$) in 1970 in South Africa to that in United Kingdom?
Ensure brevity in your answer.  0.1. What is the ratio of the Savings(current US$) of 1971 in South Africa to that in United Kingdom?
Your response must be concise. 0.13. What is the ratio of the Savings(current US$) in 1972 in South Africa to that in United Kingdom?
Offer a very short reply. 0.18. What is the ratio of the Savings(current US$) of 1973 in South Africa to that in United Kingdom?
Ensure brevity in your answer.  0.19. What is the ratio of the Savings(current US$) of 1970 in Sweden to that in United Kingdom?
Provide a succinct answer. 0.52. What is the ratio of the Savings(current US$) of 1971 in Sweden to that in United Kingdom?
Provide a short and direct response. 0.5. What is the ratio of the Savings(current US$) of 1972 in Sweden to that in United Kingdom?
Offer a terse response. 0.64. What is the ratio of the Savings(current US$) in 1973 in Sweden to that in United Kingdom?
Offer a very short reply. 0.62. What is the difference between the highest and the second highest Savings(current US$) in 1970?
Make the answer very short. 1.42e+09. What is the difference between the highest and the second highest Savings(current US$) of 1971?
Provide a short and direct response. 5.40e+08. What is the difference between the highest and the second highest Savings(current US$) of 1972?
Make the answer very short. 4.26e+09. What is the difference between the highest and the second highest Savings(current US$) of 1973?
Your answer should be compact. 4.27e+09. What is the difference between the highest and the lowest Savings(current US$) of 1970?
Your answer should be compact. 1.73e+1. What is the difference between the highest and the lowest Savings(current US$) of 1971?
Ensure brevity in your answer.  1.68e+1. What is the difference between the highest and the lowest Savings(current US$) in 1972?
Provide a short and direct response. 1.83e+1. What is the difference between the highest and the lowest Savings(current US$) in 1973?
Your answer should be compact. 2.25e+1. 